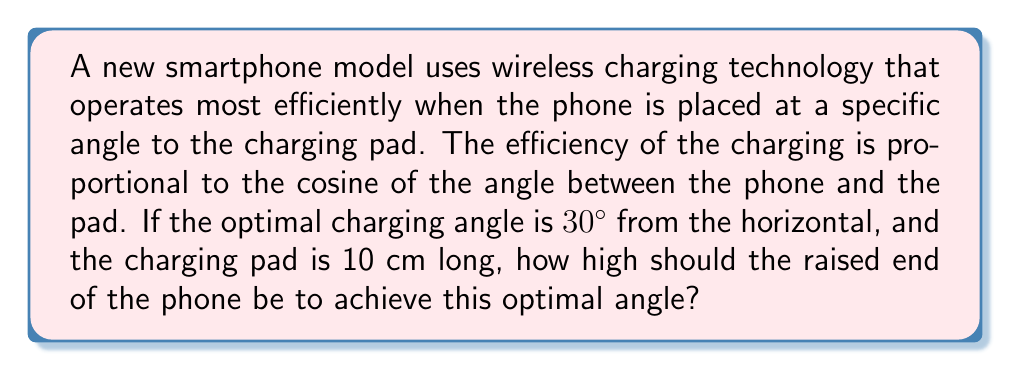Help me with this question. Let's approach this step-by-step using trigonometry:

1) We can model this situation as a right triangle, where:
   - The base is the charging pad (10 cm)
   - The height is what we're trying to find
   - The angle between the base and the hypotenuse is 30°

2) In this right triangle, we know:
   - The adjacent side (base) = 10 cm
   - The angle = 30°
   - We need to find the opposite side (height)

3) The trigonometric ratio that relates the opposite side to the adjacent side is the tangent:

   $$\tan \theta = \frac{\text{opposite}}{\text{adjacent}}$$

4) Substituting our known values:

   $$\tan 30° = \frac{\text{height}}{10\text{ cm}}$$

5) We know that $\tan 30° = \frac{1}{\sqrt{3}}$, so:

   $$\frac{1}{\sqrt{3}} = \frac{\text{height}}{10\text{ cm}}$$

6) Solving for height:

   $$\text{height} = 10\text{ cm} \cdot \frac{1}{\sqrt{3}}$$

7) Simplifying:

   $$\text{height} = \frac{10}{\sqrt{3}}\text{ cm} \approx 5.77\text{ cm}$$

Therefore, the raised end of the phone should be approximately 5.77 cm high to achieve the optimal 30° angle for wireless charging efficiency.
Answer: $\frac{10}{\sqrt{3}}\text{ cm}$ or approximately 5.77 cm 